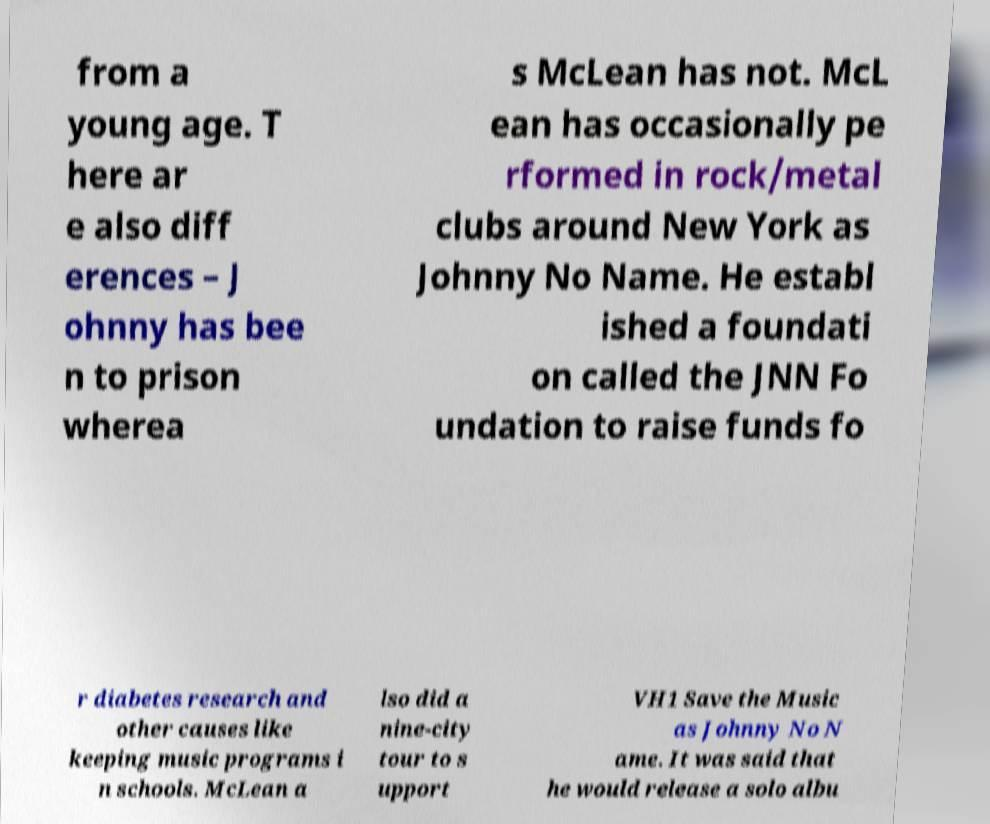Could you extract and type out the text from this image? from a young age. T here ar e also diff erences – J ohnny has bee n to prison wherea s McLean has not. McL ean has occasionally pe rformed in rock/metal clubs around New York as Johnny No Name. He establ ished a foundati on called the JNN Fo undation to raise funds fo r diabetes research and other causes like keeping music programs i n schools. McLean a lso did a nine-city tour to s upport VH1 Save the Music as Johnny No N ame. It was said that he would release a solo albu 